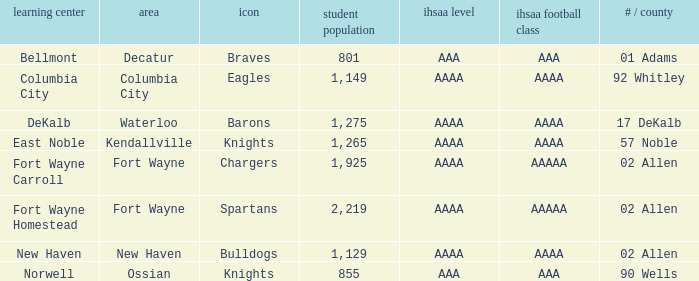What school has a mascot of the spartans with an AAAA IHSAA class and more than 1,275 enrolled? Fort Wayne Homestead. Parse the full table. {'header': ['learning center', 'area', 'icon', 'student population', 'ihsaa level', 'ihsaa football class', '# / county'], 'rows': [['Bellmont', 'Decatur', 'Braves', '801', 'AAA', 'AAA', '01 Adams'], ['Columbia City', 'Columbia City', 'Eagles', '1,149', 'AAAA', 'AAAA', '92 Whitley'], ['DeKalb', 'Waterloo', 'Barons', '1,275', 'AAAA', 'AAAA', '17 DeKalb'], ['East Noble', 'Kendallville', 'Knights', '1,265', 'AAAA', 'AAAA', '57 Noble'], ['Fort Wayne Carroll', 'Fort Wayne', 'Chargers', '1,925', 'AAAA', 'AAAAA', '02 Allen'], ['Fort Wayne Homestead', 'Fort Wayne', 'Spartans', '2,219', 'AAAA', 'AAAAA', '02 Allen'], ['New Haven', 'New Haven', 'Bulldogs', '1,129', 'AAAA', 'AAAA', '02 Allen'], ['Norwell', 'Ossian', 'Knights', '855', 'AAA', 'AAA', '90 Wells']]} 